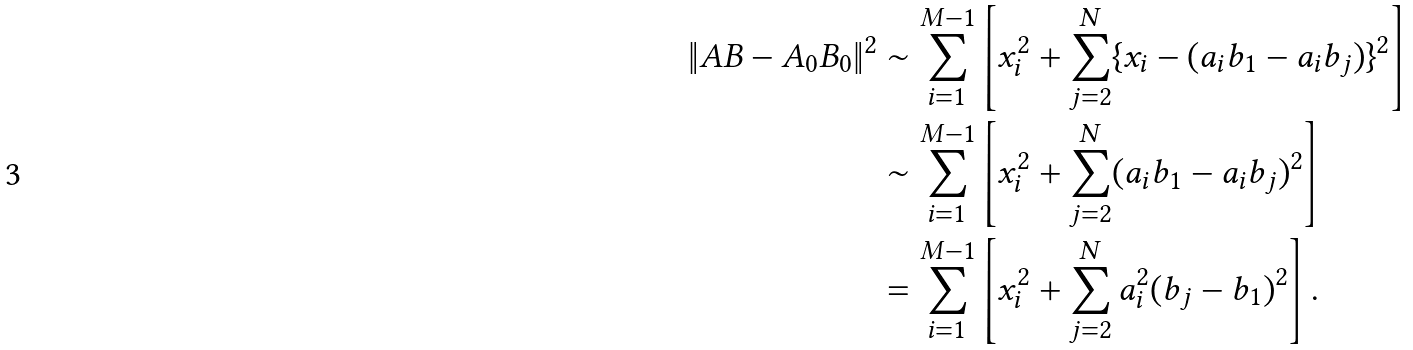Convert formula to latex. <formula><loc_0><loc_0><loc_500><loc_500>\| A B - A _ { 0 } B _ { 0 } \| ^ { 2 } & \sim \sum _ { i = 1 } ^ { M - 1 } \left [ x _ { i } ^ { 2 } + \sum _ { j = 2 } ^ { N } \{ x _ { i } - ( a _ { i } b _ { 1 } - a _ { i } b _ { j } ) \} ^ { 2 } \right ] \\ & \sim \sum _ { i = 1 } ^ { M - 1 } \left [ x _ { i } ^ { 2 } + \sum _ { j = 2 } ^ { N } ( a _ { i } b _ { 1 } - a _ { i } b _ { j } ) ^ { 2 } \right ] \\ & = \sum _ { i = 1 } ^ { M - 1 } \left [ x _ { i } ^ { 2 } + \sum _ { j = 2 } ^ { N } a _ { i } ^ { 2 } ( b _ { j } - b _ { 1 } ) ^ { 2 } \right ] .</formula> 